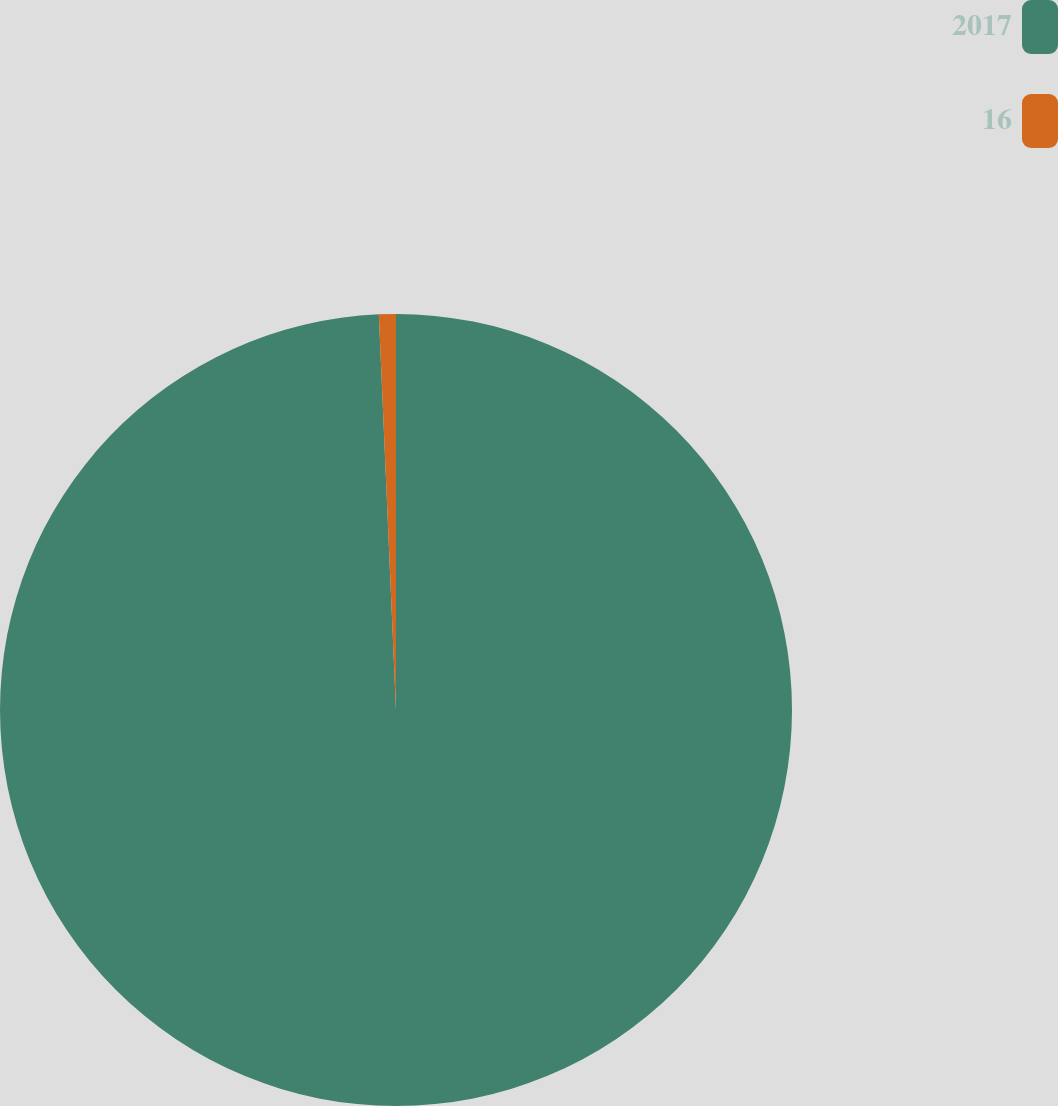<chart> <loc_0><loc_0><loc_500><loc_500><pie_chart><fcel>2017<fcel>16<nl><fcel>99.31%<fcel>0.69%<nl></chart> 